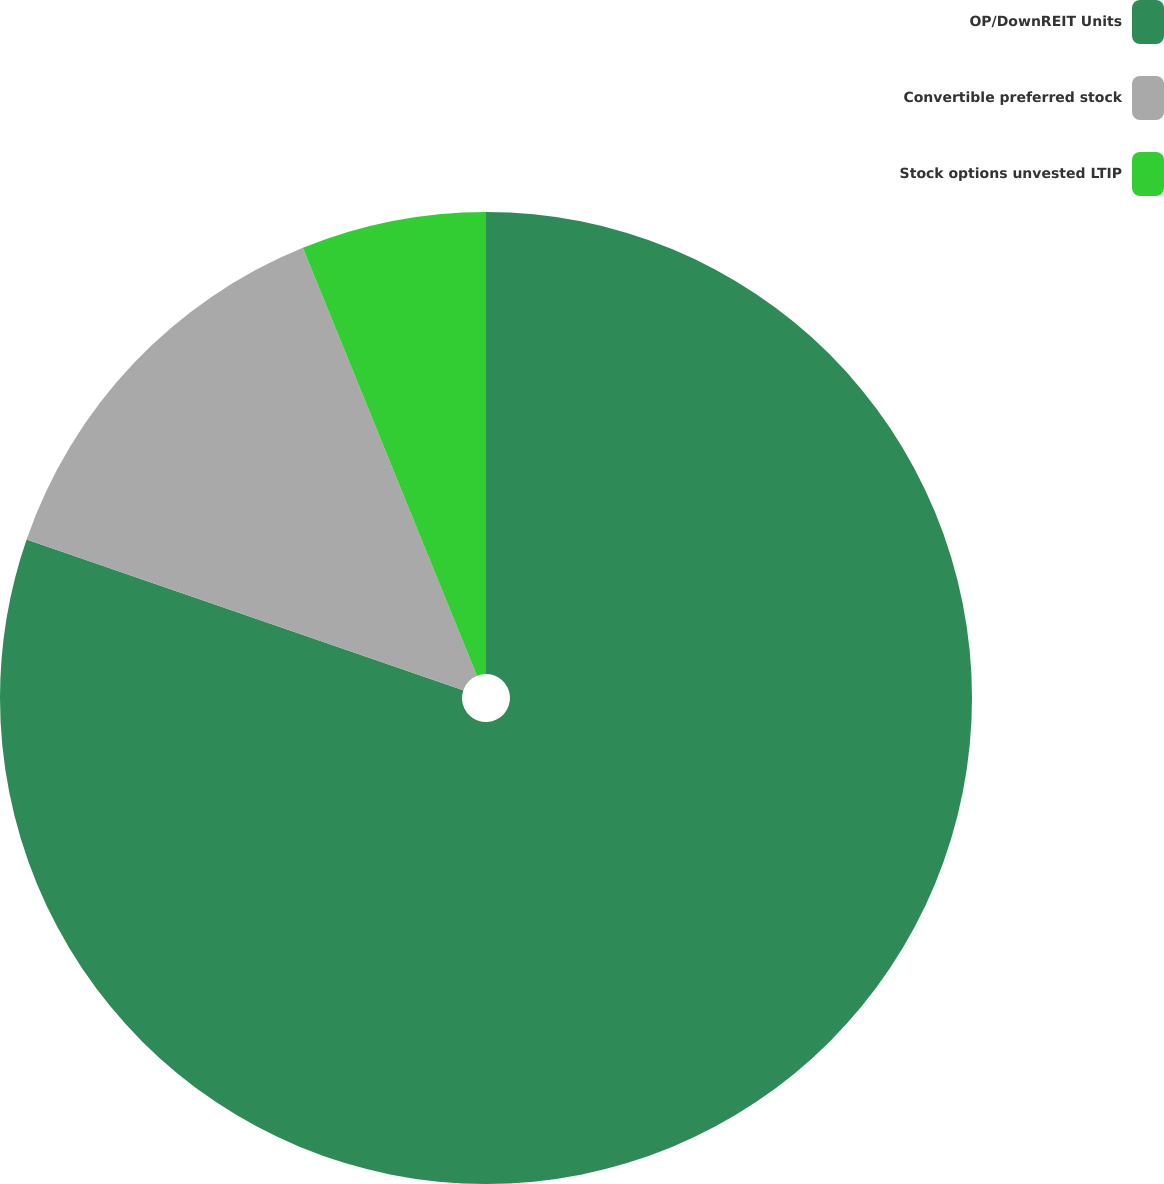Convert chart. <chart><loc_0><loc_0><loc_500><loc_500><pie_chart><fcel>OP/DownREIT Units<fcel>Convertible preferred stock<fcel>Stock options unvested LTIP<nl><fcel>80.29%<fcel>13.56%<fcel>6.15%<nl></chart> 